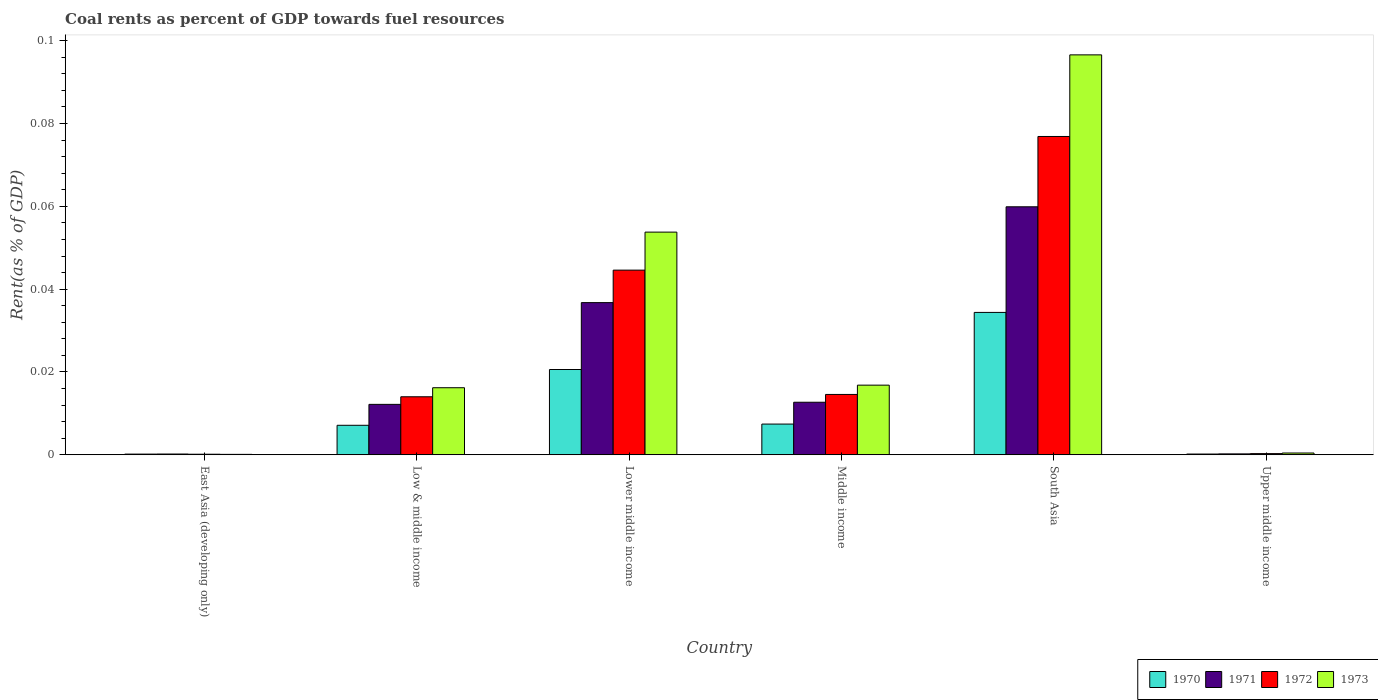Are the number of bars on each tick of the X-axis equal?
Offer a terse response. Yes. How many bars are there on the 1st tick from the left?
Offer a very short reply. 4. How many bars are there on the 3rd tick from the right?
Offer a terse response. 4. What is the coal rent in 1971 in Low & middle income?
Provide a succinct answer. 0.01. Across all countries, what is the maximum coal rent in 1970?
Your answer should be very brief. 0.03. Across all countries, what is the minimum coal rent in 1970?
Ensure brevity in your answer.  0. In which country was the coal rent in 1972 maximum?
Your answer should be compact. South Asia. In which country was the coal rent in 1971 minimum?
Make the answer very short. East Asia (developing only). What is the total coal rent in 1970 in the graph?
Your answer should be compact. 0.07. What is the difference between the coal rent in 1973 in Low & middle income and that in Middle income?
Your response must be concise. -0. What is the difference between the coal rent in 1973 in South Asia and the coal rent in 1971 in East Asia (developing only)?
Offer a very short reply. 0.1. What is the average coal rent in 1972 per country?
Provide a short and direct response. 0.03. What is the difference between the coal rent of/in 1971 and coal rent of/in 1970 in Middle income?
Give a very brief answer. 0.01. What is the ratio of the coal rent in 1973 in East Asia (developing only) to that in Low & middle income?
Keep it short and to the point. 0.01. Is the difference between the coal rent in 1971 in East Asia (developing only) and Low & middle income greater than the difference between the coal rent in 1970 in East Asia (developing only) and Low & middle income?
Provide a short and direct response. No. What is the difference between the highest and the second highest coal rent in 1972?
Keep it short and to the point. 0.03. What is the difference between the highest and the lowest coal rent in 1970?
Offer a terse response. 0.03. In how many countries, is the coal rent in 1971 greater than the average coal rent in 1971 taken over all countries?
Offer a terse response. 2. Is it the case that in every country, the sum of the coal rent in 1973 and coal rent in 1971 is greater than the sum of coal rent in 1970 and coal rent in 1972?
Offer a terse response. No. What does the 2nd bar from the left in Lower middle income represents?
Offer a very short reply. 1971. Are all the bars in the graph horizontal?
Ensure brevity in your answer.  No. What is the difference between two consecutive major ticks on the Y-axis?
Ensure brevity in your answer.  0.02. Are the values on the major ticks of Y-axis written in scientific E-notation?
Keep it short and to the point. No. Does the graph contain grids?
Ensure brevity in your answer.  No. What is the title of the graph?
Ensure brevity in your answer.  Coal rents as percent of GDP towards fuel resources. What is the label or title of the Y-axis?
Provide a succinct answer. Rent(as % of GDP). What is the Rent(as % of GDP) in 1970 in East Asia (developing only)?
Provide a short and direct response. 0. What is the Rent(as % of GDP) of 1971 in East Asia (developing only)?
Make the answer very short. 0. What is the Rent(as % of GDP) in 1972 in East Asia (developing only)?
Offer a very short reply. 0. What is the Rent(as % of GDP) of 1973 in East Asia (developing only)?
Give a very brief answer. 0. What is the Rent(as % of GDP) of 1970 in Low & middle income?
Provide a succinct answer. 0.01. What is the Rent(as % of GDP) in 1971 in Low & middle income?
Your response must be concise. 0.01. What is the Rent(as % of GDP) of 1972 in Low & middle income?
Give a very brief answer. 0.01. What is the Rent(as % of GDP) in 1973 in Low & middle income?
Offer a very short reply. 0.02. What is the Rent(as % of GDP) of 1970 in Lower middle income?
Ensure brevity in your answer.  0.02. What is the Rent(as % of GDP) in 1971 in Lower middle income?
Make the answer very short. 0.04. What is the Rent(as % of GDP) in 1972 in Lower middle income?
Your answer should be compact. 0.04. What is the Rent(as % of GDP) of 1973 in Lower middle income?
Your response must be concise. 0.05. What is the Rent(as % of GDP) in 1970 in Middle income?
Give a very brief answer. 0.01. What is the Rent(as % of GDP) in 1971 in Middle income?
Provide a short and direct response. 0.01. What is the Rent(as % of GDP) in 1972 in Middle income?
Your answer should be very brief. 0.01. What is the Rent(as % of GDP) of 1973 in Middle income?
Offer a terse response. 0.02. What is the Rent(as % of GDP) in 1970 in South Asia?
Offer a very short reply. 0.03. What is the Rent(as % of GDP) in 1971 in South Asia?
Provide a short and direct response. 0.06. What is the Rent(as % of GDP) of 1972 in South Asia?
Your response must be concise. 0.08. What is the Rent(as % of GDP) in 1973 in South Asia?
Offer a terse response. 0.1. What is the Rent(as % of GDP) of 1970 in Upper middle income?
Offer a terse response. 0. What is the Rent(as % of GDP) in 1971 in Upper middle income?
Ensure brevity in your answer.  0. What is the Rent(as % of GDP) of 1972 in Upper middle income?
Ensure brevity in your answer.  0. What is the Rent(as % of GDP) in 1973 in Upper middle income?
Your response must be concise. 0. Across all countries, what is the maximum Rent(as % of GDP) of 1970?
Your answer should be very brief. 0.03. Across all countries, what is the maximum Rent(as % of GDP) of 1971?
Your answer should be very brief. 0.06. Across all countries, what is the maximum Rent(as % of GDP) in 1972?
Provide a succinct answer. 0.08. Across all countries, what is the maximum Rent(as % of GDP) in 1973?
Offer a very short reply. 0.1. Across all countries, what is the minimum Rent(as % of GDP) in 1970?
Keep it short and to the point. 0. Across all countries, what is the minimum Rent(as % of GDP) of 1971?
Offer a very short reply. 0. Across all countries, what is the minimum Rent(as % of GDP) in 1972?
Keep it short and to the point. 0. Across all countries, what is the minimum Rent(as % of GDP) in 1973?
Keep it short and to the point. 0. What is the total Rent(as % of GDP) of 1970 in the graph?
Keep it short and to the point. 0.07. What is the total Rent(as % of GDP) of 1971 in the graph?
Your answer should be very brief. 0.12. What is the total Rent(as % of GDP) of 1972 in the graph?
Make the answer very short. 0.15. What is the total Rent(as % of GDP) in 1973 in the graph?
Keep it short and to the point. 0.18. What is the difference between the Rent(as % of GDP) of 1970 in East Asia (developing only) and that in Low & middle income?
Ensure brevity in your answer.  -0.01. What is the difference between the Rent(as % of GDP) of 1971 in East Asia (developing only) and that in Low & middle income?
Provide a succinct answer. -0.01. What is the difference between the Rent(as % of GDP) of 1972 in East Asia (developing only) and that in Low & middle income?
Keep it short and to the point. -0.01. What is the difference between the Rent(as % of GDP) of 1973 in East Asia (developing only) and that in Low & middle income?
Give a very brief answer. -0.02. What is the difference between the Rent(as % of GDP) in 1970 in East Asia (developing only) and that in Lower middle income?
Make the answer very short. -0.02. What is the difference between the Rent(as % of GDP) of 1971 in East Asia (developing only) and that in Lower middle income?
Your response must be concise. -0.04. What is the difference between the Rent(as % of GDP) in 1972 in East Asia (developing only) and that in Lower middle income?
Keep it short and to the point. -0.04. What is the difference between the Rent(as % of GDP) in 1973 in East Asia (developing only) and that in Lower middle income?
Give a very brief answer. -0.05. What is the difference between the Rent(as % of GDP) in 1970 in East Asia (developing only) and that in Middle income?
Ensure brevity in your answer.  -0.01. What is the difference between the Rent(as % of GDP) in 1971 in East Asia (developing only) and that in Middle income?
Ensure brevity in your answer.  -0.01. What is the difference between the Rent(as % of GDP) in 1972 in East Asia (developing only) and that in Middle income?
Keep it short and to the point. -0.01. What is the difference between the Rent(as % of GDP) of 1973 in East Asia (developing only) and that in Middle income?
Provide a short and direct response. -0.02. What is the difference between the Rent(as % of GDP) of 1970 in East Asia (developing only) and that in South Asia?
Make the answer very short. -0.03. What is the difference between the Rent(as % of GDP) of 1971 in East Asia (developing only) and that in South Asia?
Offer a very short reply. -0.06. What is the difference between the Rent(as % of GDP) in 1972 in East Asia (developing only) and that in South Asia?
Provide a short and direct response. -0.08. What is the difference between the Rent(as % of GDP) in 1973 in East Asia (developing only) and that in South Asia?
Keep it short and to the point. -0.1. What is the difference between the Rent(as % of GDP) of 1971 in East Asia (developing only) and that in Upper middle income?
Give a very brief answer. -0. What is the difference between the Rent(as % of GDP) of 1972 in East Asia (developing only) and that in Upper middle income?
Offer a terse response. -0. What is the difference between the Rent(as % of GDP) of 1973 in East Asia (developing only) and that in Upper middle income?
Provide a short and direct response. -0. What is the difference between the Rent(as % of GDP) of 1970 in Low & middle income and that in Lower middle income?
Your response must be concise. -0.01. What is the difference between the Rent(as % of GDP) of 1971 in Low & middle income and that in Lower middle income?
Your response must be concise. -0.02. What is the difference between the Rent(as % of GDP) of 1972 in Low & middle income and that in Lower middle income?
Ensure brevity in your answer.  -0.03. What is the difference between the Rent(as % of GDP) of 1973 in Low & middle income and that in Lower middle income?
Provide a succinct answer. -0.04. What is the difference between the Rent(as % of GDP) of 1970 in Low & middle income and that in Middle income?
Your answer should be compact. -0. What is the difference between the Rent(as % of GDP) in 1971 in Low & middle income and that in Middle income?
Provide a succinct answer. -0. What is the difference between the Rent(as % of GDP) in 1972 in Low & middle income and that in Middle income?
Offer a very short reply. -0. What is the difference between the Rent(as % of GDP) in 1973 in Low & middle income and that in Middle income?
Offer a terse response. -0. What is the difference between the Rent(as % of GDP) in 1970 in Low & middle income and that in South Asia?
Ensure brevity in your answer.  -0.03. What is the difference between the Rent(as % of GDP) in 1971 in Low & middle income and that in South Asia?
Ensure brevity in your answer.  -0.05. What is the difference between the Rent(as % of GDP) of 1972 in Low & middle income and that in South Asia?
Your response must be concise. -0.06. What is the difference between the Rent(as % of GDP) in 1973 in Low & middle income and that in South Asia?
Ensure brevity in your answer.  -0.08. What is the difference between the Rent(as % of GDP) in 1970 in Low & middle income and that in Upper middle income?
Offer a terse response. 0.01. What is the difference between the Rent(as % of GDP) of 1971 in Low & middle income and that in Upper middle income?
Your response must be concise. 0.01. What is the difference between the Rent(as % of GDP) of 1972 in Low & middle income and that in Upper middle income?
Your answer should be very brief. 0.01. What is the difference between the Rent(as % of GDP) in 1973 in Low & middle income and that in Upper middle income?
Provide a short and direct response. 0.02. What is the difference between the Rent(as % of GDP) of 1970 in Lower middle income and that in Middle income?
Your response must be concise. 0.01. What is the difference between the Rent(as % of GDP) of 1971 in Lower middle income and that in Middle income?
Ensure brevity in your answer.  0.02. What is the difference between the Rent(as % of GDP) of 1973 in Lower middle income and that in Middle income?
Your response must be concise. 0.04. What is the difference between the Rent(as % of GDP) of 1970 in Lower middle income and that in South Asia?
Your answer should be very brief. -0.01. What is the difference between the Rent(as % of GDP) of 1971 in Lower middle income and that in South Asia?
Provide a short and direct response. -0.02. What is the difference between the Rent(as % of GDP) in 1972 in Lower middle income and that in South Asia?
Your response must be concise. -0.03. What is the difference between the Rent(as % of GDP) in 1973 in Lower middle income and that in South Asia?
Ensure brevity in your answer.  -0.04. What is the difference between the Rent(as % of GDP) of 1970 in Lower middle income and that in Upper middle income?
Provide a short and direct response. 0.02. What is the difference between the Rent(as % of GDP) of 1971 in Lower middle income and that in Upper middle income?
Provide a short and direct response. 0.04. What is the difference between the Rent(as % of GDP) of 1972 in Lower middle income and that in Upper middle income?
Provide a short and direct response. 0.04. What is the difference between the Rent(as % of GDP) in 1973 in Lower middle income and that in Upper middle income?
Your answer should be very brief. 0.05. What is the difference between the Rent(as % of GDP) in 1970 in Middle income and that in South Asia?
Provide a short and direct response. -0.03. What is the difference between the Rent(as % of GDP) of 1971 in Middle income and that in South Asia?
Offer a terse response. -0.05. What is the difference between the Rent(as % of GDP) in 1972 in Middle income and that in South Asia?
Provide a short and direct response. -0.06. What is the difference between the Rent(as % of GDP) in 1973 in Middle income and that in South Asia?
Keep it short and to the point. -0.08. What is the difference between the Rent(as % of GDP) of 1970 in Middle income and that in Upper middle income?
Provide a succinct answer. 0.01. What is the difference between the Rent(as % of GDP) in 1971 in Middle income and that in Upper middle income?
Ensure brevity in your answer.  0.01. What is the difference between the Rent(as % of GDP) in 1972 in Middle income and that in Upper middle income?
Keep it short and to the point. 0.01. What is the difference between the Rent(as % of GDP) of 1973 in Middle income and that in Upper middle income?
Offer a terse response. 0.02. What is the difference between the Rent(as % of GDP) in 1970 in South Asia and that in Upper middle income?
Your response must be concise. 0.03. What is the difference between the Rent(as % of GDP) of 1971 in South Asia and that in Upper middle income?
Make the answer very short. 0.06. What is the difference between the Rent(as % of GDP) in 1972 in South Asia and that in Upper middle income?
Ensure brevity in your answer.  0.08. What is the difference between the Rent(as % of GDP) in 1973 in South Asia and that in Upper middle income?
Provide a short and direct response. 0.1. What is the difference between the Rent(as % of GDP) in 1970 in East Asia (developing only) and the Rent(as % of GDP) in 1971 in Low & middle income?
Keep it short and to the point. -0.01. What is the difference between the Rent(as % of GDP) of 1970 in East Asia (developing only) and the Rent(as % of GDP) of 1972 in Low & middle income?
Provide a succinct answer. -0.01. What is the difference between the Rent(as % of GDP) in 1970 in East Asia (developing only) and the Rent(as % of GDP) in 1973 in Low & middle income?
Your response must be concise. -0.02. What is the difference between the Rent(as % of GDP) of 1971 in East Asia (developing only) and the Rent(as % of GDP) of 1972 in Low & middle income?
Offer a terse response. -0.01. What is the difference between the Rent(as % of GDP) in 1971 in East Asia (developing only) and the Rent(as % of GDP) in 1973 in Low & middle income?
Keep it short and to the point. -0.02. What is the difference between the Rent(as % of GDP) in 1972 in East Asia (developing only) and the Rent(as % of GDP) in 1973 in Low & middle income?
Keep it short and to the point. -0.02. What is the difference between the Rent(as % of GDP) in 1970 in East Asia (developing only) and the Rent(as % of GDP) in 1971 in Lower middle income?
Ensure brevity in your answer.  -0.04. What is the difference between the Rent(as % of GDP) of 1970 in East Asia (developing only) and the Rent(as % of GDP) of 1972 in Lower middle income?
Your answer should be very brief. -0.04. What is the difference between the Rent(as % of GDP) in 1970 in East Asia (developing only) and the Rent(as % of GDP) in 1973 in Lower middle income?
Offer a very short reply. -0.05. What is the difference between the Rent(as % of GDP) of 1971 in East Asia (developing only) and the Rent(as % of GDP) of 1972 in Lower middle income?
Keep it short and to the point. -0.04. What is the difference between the Rent(as % of GDP) in 1971 in East Asia (developing only) and the Rent(as % of GDP) in 1973 in Lower middle income?
Give a very brief answer. -0.05. What is the difference between the Rent(as % of GDP) of 1972 in East Asia (developing only) and the Rent(as % of GDP) of 1973 in Lower middle income?
Ensure brevity in your answer.  -0.05. What is the difference between the Rent(as % of GDP) in 1970 in East Asia (developing only) and the Rent(as % of GDP) in 1971 in Middle income?
Make the answer very short. -0.01. What is the difference between the Rent(as % of GDP) of 1970 in East Asia (developing only) and the Rent(as % of GDP) of 1972 in Middle income?
Your answer should be very brief. -0.01. What is the difference between the Rent(as % of GDP) in 1970 in East Asia (developing only) and the Rent(as % of GDP) in 1973 in Middle income?
Provide a succinct answer. -0.02. What is the difference between the Rent(as % of GDP) of 1971 in East Asia (developing only) and the Rent(as % of GDP) of 1972 in Middle income?
Keep it short and to the point. -0.01. What is the difference between the Rent(as % of GDP) of 1971 in East Asia (developing only) and the Rent(as % of GDP) of 1973 in Middle income?
Offer a terse response. -0.02. What is the difference between the Rent(as % of GDP) in 1972 in East Asia (developing only) and the Rent(as % of GDP) in 1973 in Middle income?
Your answer should be very brief. -0.02. What is the difference between the Rent(as % of GDP) in 1970 in East Asia (developing only) and the Rent(as % of GDP) in 1971 in South Asia?
Provide a short and direct response. -0.06. What is the difference between the Rent(as % of GDP) of 1970 in East Asia (developing only) and the Rent(as % of GDP) of 1972 in South Asia?
Your answer should be very brief. -0.08. What is the difference between the Rent(as % of GDP) of 1970 in East Asia (developing only) and the Rent(as % of GDP) of 1973 in South Asia?
Your answer should be very brief. -0.1. What is the difference between the Rent(as % of GDP) of 1971 in East Asia (developing only) and the Rent(as % of GDP) of 1972 in South Asia?
Give a very brief answer. -0.08. What is the difference between the Rent(as % of GDP) of 1971 in East Asia (developing only) and the Rent(as % of GDP) of 1973 in South Asia?
Your response must be concise. -0.1. What is the difference between the Rent(as % of GDP) in 1972 in East Asia (developing only) and the Rent(as % of GDP) in 1973 in South Asia?
Give a very brief answer. -0.1. What is the difference between the Rent(as % of GDP) in 1970 in East Asia (developing only) and the Rent(as % of GDP) in 1971 in Upper middle income?
Offer a very short reply. -0. What is the difference between the Rent(as % of GDP) in 1970 in East Asia (developing only) and the Rent(as % of GDP) in 1972 in Upper middle income?
Keep it short and to the point. -0. What is the difference between the Rent(as % of GDP) of 1970 in East Asia (developing only) and the Rent(as % of GDP) of 1973 in Upper middle income?
Your answer should be very brief. -0. What is the difference between the Rent(as % of GDP) in 1971 in East Asia (developing only) and the Rent(as % of GDP) in 1972 in Upper middle income?
Provide a succinct answer. -0. What is the difference between the Rent(as % of GDP) of 1971 in East Asia (developing only) and the Rent(as % of GDP) of 1973 in Upper middle income?
Make the answer very short. -0. What is the difference between the Rent(as % of GDP) in 1972 in East Asia (developing only) and the Rent(as % of GDP) in 1973 in Upper middle income?
Provide a short and direct response. -0. What is the difference between the Rent(as % of GDP) of 1970 in Low & middle income and the Rent(as % of GDP) of 1971 in Lower middle income?
Keep it short and to the point. -0.03. What is the difference between the Rent(as % of GDP) of 1970 in Low & middle income and the Rent(as % of GDP) of 1972 in Lower middle income?
Make the answer very short. -0.04. What is the difference between the Rent(as % of GDP) of 1970 in Low & middle income and the Rent(as % of GDP) of 1973 in Lower middle income?
Your answer should be very brief. -0.05. What is the difference between the Rent(as % of GDP) of 1971 in Low & middle income and the Rent(as % of GDP) of 1972 in Lower middle income?
Make the answer very short. -0.03. What is the difference between the Rent(as % of GDP) in 1971 in Low & middle income and the Rent(as % of GDP) in 1973 in Lower middle income?
Provide a succinct answer. -0.04. What is the difference between the Rent(as % of GDP) in 1972 in Low & middle income and the Rent(as % of GDP) in 1973 in Lower middle income?
Your response must be concise. -0.04. What is the difference between the Rent(as % of GDP) of 1970 in Low & middle income and the Rent(as % of GDP) of 1971 in Middle income?
Your response must be concise. -0.01. What is the difference between the Rent(as % of GDP) in 1970 in Low & middle income and the Rent(as % of GDP) in 1972 in Middle income?
Offer a terse response. -0.01. What is the difference between the Rent(as % of GDP) in 1970 in Low & middle income and the Rent(as % of GDP) in 1973 in Middle income?
Your answer should be very brief. -0.01. What is the difference between the Rent(as % of GDP) in 1971 in Low & middle income and the Rent(as % of GDP) in 1972 in Middle income?
Offer a terse response. -0. What is the difference between the Rent(as % of GDP) in 1971 in Low & middle income and the Rent(as % of GDP) in 1973 in Middle income?
Keep it short and to the point. -0. What is the difference between the Rent(as % of GDP) of 1972 in Low & middle income and the Rent(as % of GDP) of 1973 in Middle income?
Offer a terse response. -0. What is the difference between the Rent(as % of GDP) in 1970 in Low & middle income and the Rent(as % of GDP) in 1971 in South Asia?
Provide a short and direct response. -0.05. What is the difference between the Rent(as % of GDP) of 1970 in Low & middle income and the Rent(as % of GDP) of 1972 in South Asia?
Ensure brevity in your answer.  -0.07. What is the difference between the Rent(as % of GDP) in 1970 in Low & middle income and the Rent(as % of GDP) in 1973 in South Asia?
Your response must be concise. -0.09. What is the difference between the Rent(as % of GDP) in 1971 in Low & middle income and the Rent(as % of GDP) in 1972 in South Asia?
Offer a terse response. -0.06. What is the difference between the Rent(as % of GDP) of 1971 in Low & middle income and the Rent(as % of GDP) of 1973 in South Asia?
Ensure brevity in your answer.  -0.08. What is the difference between the Rent(as % of GDP) in 1972 in Low & middle income and the Rent(as % of GDP) in 1973 in South Asia?
Provide a short and direct response. -0.08. What is the difference between the Rent(as % of GDP) of 1970 in Low & middle income and the Rent(as % of GDP) of 1971 in Upper middle income?
Give a very brief answer. 0.01. What is the difference between the Rent(as % of GDP) of 1970 in Low & middle income and the Rent(as % of GDP) of 1972 in Upper middle income?
Give a very brief answer. 0.01. What is the difference between the Rent(as % of GDP) in 1970 in Low & middle income and the Rent(as % of GDP) in 1973 in Upper middle income?
Provide a succinct answer. 0.01. What is the difference between the Rent(as % of GDP) in 1971 in Low & middle income and the Rent(as % of GDP) in 1972 in Upper middle income?
Provide a short and direct response. 0.01. What is the difference between the Rent(as % of GDP) in 1971 in Low & middle income and the Rent(as % of GDP) in 1973 in Upper middle income?
Ensure brevity in your answer.  0.01. What is the difference between the Rent(as % of GDP) of 1972 in Low & middle income and the Rent(as % of GDP) of 1973 in Upper middle income?
Provide a short and direct response. 0.01. What is the difference between the Rent(as % of GDP) in 1970 in Lower middle income and the Rent(as % of GDP) in 1971 in Middle income?
Provide a short and direct response. 0.01. What is the difference between the Rent(as % of GDP) in 1970 in Lower middle income and the Rent(as % of GDP) in 1972 in Middle income?
Your response must be concise. 0.01. What is the difference between the Rent(as % of GDP) in 1970 in Lower middle income and the Rent(as % of GDP) in 1973 in Middle income?
Keep it short and to the point. 0. What is the difference between the Rent(as % of GDP) of 1971 in Lower middle income and the Rent(as % of GDP) of 1972 in Middle income?
Your answer should be very brief. 0.02. What is the difference between the Rent(as % of GDP) of 1971 in Lower middle income and the Rent(as % of GDP) of 1973 in Middle income?
Give a very brief answer. 0.02. What is the difference between the Rent(as % of GDP) of 1972 in Lower middle income and the Rent(as % of GDP) of 1973 in Middle income?
Your answer should be very brief. 0.03. What is the difference between the Rent(as % of GDP) of 1970 in Lower middle income and the Rent(as % of GDP) of 1971 in South Asia?
Keep it short and to the point. -0.04. What is the difference between the Rent(as % of GDP) of 1970 in Lower middle income and the Rent(as % of GDP) of 1972 in South Asia?
Provide a succinct answer. -0.06. What is the difference between the Rent(as % of GDP) in 1970 in Lower middle income and the Rent(as % of GDP) in 1973 in South Asia?
Make the answer very short. -0.08. What is the difference between the Rent(as % of GDP) in 1971 in Lower middle income and the Rent(as % of GDP) in 1972 in South Asia?
Offer a terse response. -0.04. What is the difference between the Rent(as % of GDP) of 1971 in Lower middle income and the Rent(as % of GDP) of 1973 in South Asia?
Offer a terse response. -0.06. What is the difference between the Rent(as % of GDP) in 1972 in Lower middle income and the Rent(as % of GDP) in 1973 in South Asia?
Ensure brevity in your answer.  -0.05. What is the difference between the Rent(as % of GDP) of 1970 in Lower middle income and the Rent(as % of GDP) of 1971 in Upper middle income?
Make the answer very short. 0.02. What is the difference between the Rent(as % of GDP) of 1970 in Lower middle income and the Rent(as % of GDP) of 1972 in Upper middle income?
Keep it short and to the point. 0.02. What is the difference between the Rent(as % of GDP) in 1970 in Lower middle income and the Rent(as % of GDP) in 1973 in Upper middle income?
Your response must be concise. 0.02. What is the difference between the Rent(as % of GDP) in 1971 in Lower middle income and the Rent(as % of GDP) in 1972 in Upper middle income?
Provide a succinct answer. 0.04. What is the difference between the Rent(as % of GDP) of 1971 in Lower middle income and the Rent(as % of GDP) of 1973 in Upper middle income?
Ensure brevity in your answer.  0.04. What is the difference between the Rent(as % of GDP) in 1972 in Lower middle income and the Rent(as % of GDP) in 1973 in Upper middle income?
Give a very brief answer. 0.04. What is the difference between the Rent(as % of GDP) of 1970 in Middle income and the Rent(as % of GDP) of 1971 in South Asia?
Provide a succinct answer. -0.05. What is the difference between the Rent(as % of GDP) in 1970 in Middle income and the Rent(as % of GDP) in 1972 in South Asia?
Provide a short and direct response. -0.07. What is the difference between the Rent(as % of GDP) of 1970 in Middle income and the Rent(as % of GDP) of 1973 in South Asia?
Ensure brevity in your answer.  -0.09. What is the difference between the Rent(as % of GDP) in 1971 in Middle income and the Rent(as % of GDP) in 1972 in South Asia?
Give a very brief answer. -0.06. What is the difference between the Rent(as % of GDP) of 1971 in Middle income and the Rent(as % of GDP) of 1973 in South Asia?
Provide a short and direct response. -0.08. What is the difference between the Rent(as % of GDP) in 1972 in Middle income and the Rent(as % of GDP) in 1973 in South Asia?
Provide a short and direct response. -0.08. What is the difference between the Rent(as % of GDP) of 1970 in Middle income and the Rent(as % of GDP) of 1971 in Upper middle income?
Provide a succinct answer. 0.01. What is the difference between the Rent(as % of GDP) in 1970 in Middle income and the Rent(as % of GDP) in 1972 in Upper middle income?
Offer a terse response. 0.01. What is the difference between the Rent(as % of GDP) in 1970 in Middle income and the Rent(as % of GDP) in 1973 in Upper middle income?
Ensure brevity in your answer.  0.01. What is the difference between the Rent(as % of GDP) of 1971 in Middle income and the Rent(as % of GDP) of 1972 in Upper middle income?
Your response must be concise. 0.01. What is the difference between the Rent(as % of GDP) in 1971 in Middle income and the Rent(as % of GDP) in 1973 in Upper middle income?
Provide a short and direct response. 0.01. What is the difference between the Rent(as % of GDP) in 1972 in Middle income and the Rent(as % of GDP) in 1973 in Upper middle income?
Ensure brevity in your answer.  0.01. What is the difference between the Rent(as % of GDP) in 1970 in South Asia and the Rent(as % of GDP) in 1971 in Upper middle income?
Offer a very short reply. 0.03. What is the difference between the Rent(as % of GDP) in 1970 in South Asia and the Rent(as % of GDP) in 1972 in Upper middle income?
Make the answer very short. 0.03. What is the difference between the Rent(as % of GDP) in 1970 in South Asia and the Rent(as % of GDP) in 1973 in Upper middle income?
Offer a terse response. 0.03. What is the difference between the Rent(as % of GDP) of 1971 in South Asia and the Rent(as % of GDP) of 1972 in Upper middle income?
Offer a terse response. 0.06. What is the difference between the Rent(as % of GDP) in 1971 in South Asia and the Rent(as % of GDP) in 1973 in Upper middle income?
Provide a short and direct response. 0.06. What is the difference between the Rent(as % of GDP) in 1972 in South Asia and the Rent(as % of GDP) in 1973 in Upper middle income?
Ensure brevity in your answer.  0.08. What is the average Rent(as % of GDP) of 1970 per country?
Your response must be concise. 0.01. What is the average Rent(as % of GDP) of 1971 per country?
Your answer should be very brief. 0.02. What is the average Rent(as % of GDP) in 1972 per country?
Your response must be concise. 0.03. What is the average Rent(as % of GDP) in 1973 per country?
Give a very brief answer. 0.03. What is the difference between the Rent(as % of GDP) in 1970 and Rent(as % of GDP) in 1971 in East Asia (developing only)?
Give a very brief answer. -0. What is the difference between the Rent(as % of GDP) in 1971 and Rent(as % of GDP) in 1972 in East Asia (developing only)?
Provide a succinct answer. 0. What is the difference between the Rent(as % of GDP) in 1970 and Rent(as % of GDP) in 1971 in Low & middle income?
Ensure brevity in your answer.  -0.01. What is the difference between the Rent(as % of GDP) in 1970 and Rent(as % of GDP) in 1972 in Low & middle income?
Give a very brief answer. -0.01. What is the difference between the Rent(as % of GDP) in 1970 and Rent(as % of GDP) in 1973 in Low & middle income?
Your response must be concise. -0.01. What is the difference between the Rent(as % of GDP) of 1971 and Rent(as % of GDP) of 1972 in Low & middle income?
Your answer should be compact. -0. What is the difference between the Rent(as % of GDP) in 1971 and Rent(as % of GDP) in 1973 in Low & middle income?
Ensure brevity in your answer.  -0. What is the difference between the Rent(as % of GDP) of 1972 and Rent(as % of GDP) of 1973 in Low & middle income?
Provide a short and direct response. -0. What is the difference between the Rent(as % of GDP) of 1970 and Rent(as % of GDP) of 1971 in Lower middle income?
Provide a succinct answer. -0.02. What is the difference between the Rent(as % of GDP) in 1970 and Rent(as % of GDP) in 1972 in Lower middle income?
Provide a succinct answer. -0.02. What is the difference between the Rent(as % of GDP) of 1970 and Rent(as % of GDP) of 1973 in Lower middle income?
Your answer should be compact. -0.03. What is the difference between the Rent(as % of GDP) of 1971 and Rent(as % of GDP) of 1972 in Lower middle income?
Keep it short and to the point. -0.01. What is the difference between the Rent(as % of GDP) in 1971 and Rent(as % of GDP) in 1973 in Lower middle income?
Your response must be concise. -0.02. What is the difference between the Rent(as % of GDP) of 1972 and Rent(as % of GDP) of 1973 in Lower middle income?
Your response must be concise. -0.01. What is the difference between the Rent(as % of GDP) in 1970 and Rent(as % of GDP) in 1971 in Middle income?
Provide a short and direct response. -0.01. What is the difference between the Rent(as % of GDP) of 1970 and Rent(as % of GDP) of 1972 in Middle income?
Ensure brevity in your answer.  -0.01. What is the difference between the Rent(as % of GDP) of 1970 and Rent(as % of GDP) of 1973 in Middle income?
Make the answer very short. -0.01. What is the difference between the Rent(as % of GDP) of 1971 and Rent(as % of GDP) of 1972 in Middle income?
Your response must be concise. -0. What is the difference between the Rent(as % of GDP) of 1971 and Rent(as % of GDP) of 1973 in Middle income?
Ensure brevity in your answer.  -0. What is the difference between the Rent(as % of GDP) in 1972 and Rent(as % of GDP) in 1973 in Middle income?
Ensure brevity in your answer.  -0. What is the difference between the Rent(as % of GDP) in 1970 and Rent(as % of GDP) in 1971 in South Asia?
Provide a short and direct response. -0.03. What is the difference between the Rent(as % of GDP) in 1970 and Rent(as % of GDP) in 1972 in South Asia?
Your answer should be very brief. -0.04. What is the difference between the Rent(as % of GDP) in 1970 and Rent(as % of GDP) in 1973 in South Asia?
Ensure brevity in your answer.  -0.06. What is the difference between the Rent(as % of GDP) of 1971 and Rent(as % of GDP) of 1972 in South Asia?
Provide a short and direct response. -0.02. What is the difference between the Rent(as % of GDP) in 1971 and Rent(as % of GDP) in 1973 in South Asia?
Your answer should be very brief. -0.04. What is the difference between the Rent(as % of GDP) in 1972 and Rent(as % of GDP) in 1973 in South Asia?
Make the answer very short. -0.02. What is the difference between the Rent(as % of GDP) of 1970 and Rent(as % of GDP) of 1972 in Upper middle income?
Give a very brief answer. -0. What is the difference between the Rent(as % of GDP) of 1970 and Rent(as % of GDP) of 1973 in Upper middle income?
Offer a terse response. -0. What is the difference between the Rent(as % of GDP) in 1971 and Rent(as % of GDP) in 1972 in Upper middle income?
Make the answer very short. -0. What is the difference between the Rent(as % of GDP) in 1971 and Rent(as % of GDP) in 1973 in Upper middle income?
Make the answer very short. -0. What is the difference between the Rent(as % of GDP) of 1972 and Rent(as % of GDP) of 1973 in Upper middle income?
Your answer should be very brief. -0. What is the ratio of the Rent(as % of GDP) of 1970 in East Asia (developing only) to that in Low & middle income?
Give a very brief answer. 0.02. What is the ratio of the Rent(as % of GDP) of 1971 in East Asia (developing only) to that in Low & middle income?
Provide a short and direct response. 0.02. What is the ratio of the Rent(as % of GDP) of 1972 in East Asia (developing only) to that in Low & middle income?
Your answer should be compact. 0.01. What is the ratio of the Rent(as % of GDP) in 1973 in East Asia (developing only) to that in Low & middle income?
Provide a short and direct response. 0.01. What is the ratio of the Rent(as % of GDP) in 1970 in East Asia (developing only) to that in Lower middle income?
Provide a succinct answer. 0.01. What is the ratio of the Rent(as % of GDP) in 1971 in East Asia (developing only) to that in Lower middle income?
Make the answer very short. 0.01. What is the ratio of the Rent(as % of GDP) in 1972 in East Asia (developing only) to that in Lower middle income?
Ensure brevity in your answer.  0. What is the ratio of the Rent(as % of GDP) of 1973 in East Asia (developing only) to that in Lower middle income?
Make the answer very short. 0. What is the ratio of the Rent(as % of GDP) of 1970 in East Asia (developing only) to that in Middle income?
Ensure brevity in your answer.  0.02. What is the ratio of the Rent(as % of GDP) of 1971 in East Asia (developing only) to that in Middle income?
Your answer should be very brief. 0.01. What is the ratio of the Rent(as % of GDP) in 1972 in East Asia (developing only) to that in Middle income?
Your response must be concise. 0.01. What is the ratio of the Rent(as % of GDP) of 1973 in East Asia (developing only) to that in Middle income?
Ensure brevity in your answer.  0.01. What is the ratio of the Rent(as % of GDP) in 1970 in East Asia (developing only) to that in South Asia?
Your answer should be very brief. 0. What is the ratio of the Rent(as % of GDP) of 1971 in East Asia (developing only) to that in South Asia?
Provide a succinct answer. 0. What is the ratio of the Rent(as % of GDP) of 1972 in East Asia (developing only) to that in South Asia?
Provide a succinct answer. 0. What is the ratio of the Rent(as % of GDP) in 1973 in East Asia (developing only) to that in South Asia?
Give a very brief answer. 0. What is the ratio of the Rent(as % of GDP) of 1970 in East Asia (developing only) to that in Upper middle income?
Provide a short and direct response. 0.91. What is the ratio of the Rent(as % of GDP) of 1971 in East Asia (developing only) to that in Upper middle income?
Keep it short and to the point. 0.86. What is the ratio of the Rent(as % of GDP) in 1972 in East Asia (developing only) to that in Upper middle income?
Keep it short and to the point. 0.48. What is the ratio of the Rent(as % of GDP) in 1973 in East Asia (developing only) to that in Upper middle income?
Your answer should be very brief. 0.24. What is the ratio of the Rent(as % of GDP) in 1970 in Low & middle income to that in Lower middle income?
Provide a succinct answer. 0.35. What is the ratio of the Rent(as % of GDP) of 1971 in Low & middle income to that in Lower middle income?
Provide a succinct answer. 0.33. What is the ratio of the Rent(as % of GDP) of 1972 in Low & middle income to that in Lower middle income?
Ensure brevity in your answer.  0.31. What is the ratio of the Rent(as % of GDP) in 1973 in Low & middle income to that in Lower middle income?
Your response must be concise. 0.3. What is the ratio of the Rent(as % of GDP) of 1970 in Low & middle income to that in Middle income?
Ensure brevity in your answer.  0.96. What is the ratio of the Rent(as % of GDP) of 1971 in Low & middle income to that in Middle income?
Offer a terse response. 0.96. What is the ratio of the Rent(as % of GDP) in 1972 in Low & middle income to that in Middle income?
Your response must be concise. 0.96. What is the ratio of the Rent(as % of GDP) of 1973 in Low & middle income to that in Middle income?
Your answer should be compact. 0.96. What is the ratio of the Rent(as % of GDP) of 1970 in Low & middle income to that in South Asia?
Provide a succinct answer. 0.21. What is the ratio of the Rent(as % of GDP) of 1971 in Low & middle income to that in South Asia?
Provide a succinct answer. 0.2. What is the ratio of the Rent(as % of GDP) in 1972 in Low & middle income to that in South Asia?
Keep it short and to the point. 0.18. What is the ratio of the Rent(as % of GDP) of 1973 in Low & middle income to that in South Asia?
Offer a terse response. 0.17. What is the ratio of the Rent(as % of GDP) of 1970 in Low & middle income to that in Upper middle income?
Make the answer very short. 38.77. What is the ratio of the Rent(as % of GDP) of 1971 in Low & middle income to that in Upper middle income?
Keep it short and to the point. 55.66. What is the ratio of the Rent(as % of GDP) in 1972 in Low & middle income to that in Upper middle income?
Give a very brief answer. 49.28. What is the ratio of the Rent(as % of GDP) in 1973 in Low & middle income to that in Upper middle income?
Provide a short and direct response. 37.59. What is the ratio of the Rent(as % of GDP) in 1970 in Lower middle income to that in Middle income?
Offer a very short reply. 2.78. What is the ratio of the Rent(as % of GDP) of 1971 in Lower middle income to that in Middle income?
Your answer should be very brief. 2.9. What is the ratio of the Rent(as % of GDP) of 1972 in Lower middle income to that in Middle income?
Provide a succinct answer. 3.06. What is the ratio of the Rent(as % of GDP) in 1973 in Lower middle income to that in Middle income?
Provide a short and direct response. 3.2. What is the ratio of the Rent(as % of GDP) in 1970 in Lower middle income to that in South Asia?
Provide a succinct answer. 0.6. What is the ratio of the Rent(as % of GDP) in 1971 in Lower middle income to that in South Asia?
Offer a very short reply. 0.61. What is the ratio of the Rent(as % of GDP) in 1972 in Lower middle income to that in South Asia?
Provide a short and direct response. 0.58. What is the ratio of the Rent(as % of GDP) of 1973 in Lower middle income to that in South Asia?
Provide a succinct answer. 0.56. What is the ratio of the Rent(as % of GDP) of 1970 in Lower middle income to that in Upper middle income?
Your answer should be very brief. 112.03. What is the ratio of the Rent(as % of GDP) of 1971 in Lower middle income to that in Upper middle income?
Your answer should be very brief. 167.98. What is the ratio of the Rent(as % of GDP) of 1972 in Lower middle income to that in Upper middle income?
Your response must be concise. 156.82. What is the ratio of the Rent(as % of GDP) in 1973 in Lower middle income to that in Upper middle income?
Keep it short and to the point. 124.82. What is the ratio of the Rent(as % of GDP) in 1970 in Middle income to that in South Asia?
Provide a succinct answer. 0.22. What is the ratio of the Rent(as % of GDP) of 1971 in Middle income to that in South Asia?
Ensure brevity in your answer.  0.21. What is the ratio of the Rent(as % of GDP) of 1972 in Middle income to that in South Asia?
Provide a succinct answer. 0.19. What is the ratio of the Rent(as % of GDP) of 1973 in Middle income to that in South Asia?
Ensure brevity in your answer.  0.17. What is the ratio of the Rent(as % of GDP) of 1970 in Middle income to that in Upper middle income?
Provide a succinct answer. 40.36. What is the ratio of the Rent(as % of GDP) in 1971 in Middle income to that in Upper middle income?
Your answer should be very brief. 58.01. What is the ratio of the Rent(as % of GDP) in 1972 in Middle income to that in Upper middle income?
Your response must be concise. 51.25. What is the ratio of the Rent(as % of GDP) in 1973 in Middle income to that in Upper middle income?
Ensure brevity in your answer.  39.04. What is the ratio of the Rent(as % of GDP) in 1970 in South Asia to that in Upper middle income?
Your response must be concise. 187.05. What is the ratio of the Rent(as % of GDP) of 1971 in South Asia to that in Upper middle income?
Ensure brevity in your answer.  273.74. What is the ratio of the Rent(as % of GDP) of 1972 in South Asia to that in Upper middle income?
Your answer should be compact. 270.32. What is the ratio of the Rent(as % of GDP) of 1973 in South Asia to that in Upper middle income?
Your answer should be compact. 224.18. What is the difference between the highest and the second highest Rent(as % of GDP) in 1970?
Make the answer very short. 0.01. What is the difference between the highest and the second highest Rent(as % of GDP) in 1971?
Make the answer very short. 0.02. What is the difference between the highest and the second highest Rent(as % of GDP) of 1972?
Make the answer very short. 0.03. What is the difference between the highest and the second highest Rent(as % of GDP) of 1973?
Provide a succinct answer. 0.04. What is the difference between the highest and the lowest Rent(as % of GDP) of 1970?
Ensure brevity in your answer.  0.03. What is the difference between the highest and the lowest Rent(as % of GDP) of 1971?
Give a very brief answer. 0.06. What is the difference between the highest and the lowest Rent(as % of GDP) in 1972?
Your response must be concise. 0.08. What is the difference between the highest and the lowest Rent(as % of GDP) of 1973?
Provide a succinct answer. 0.1. 